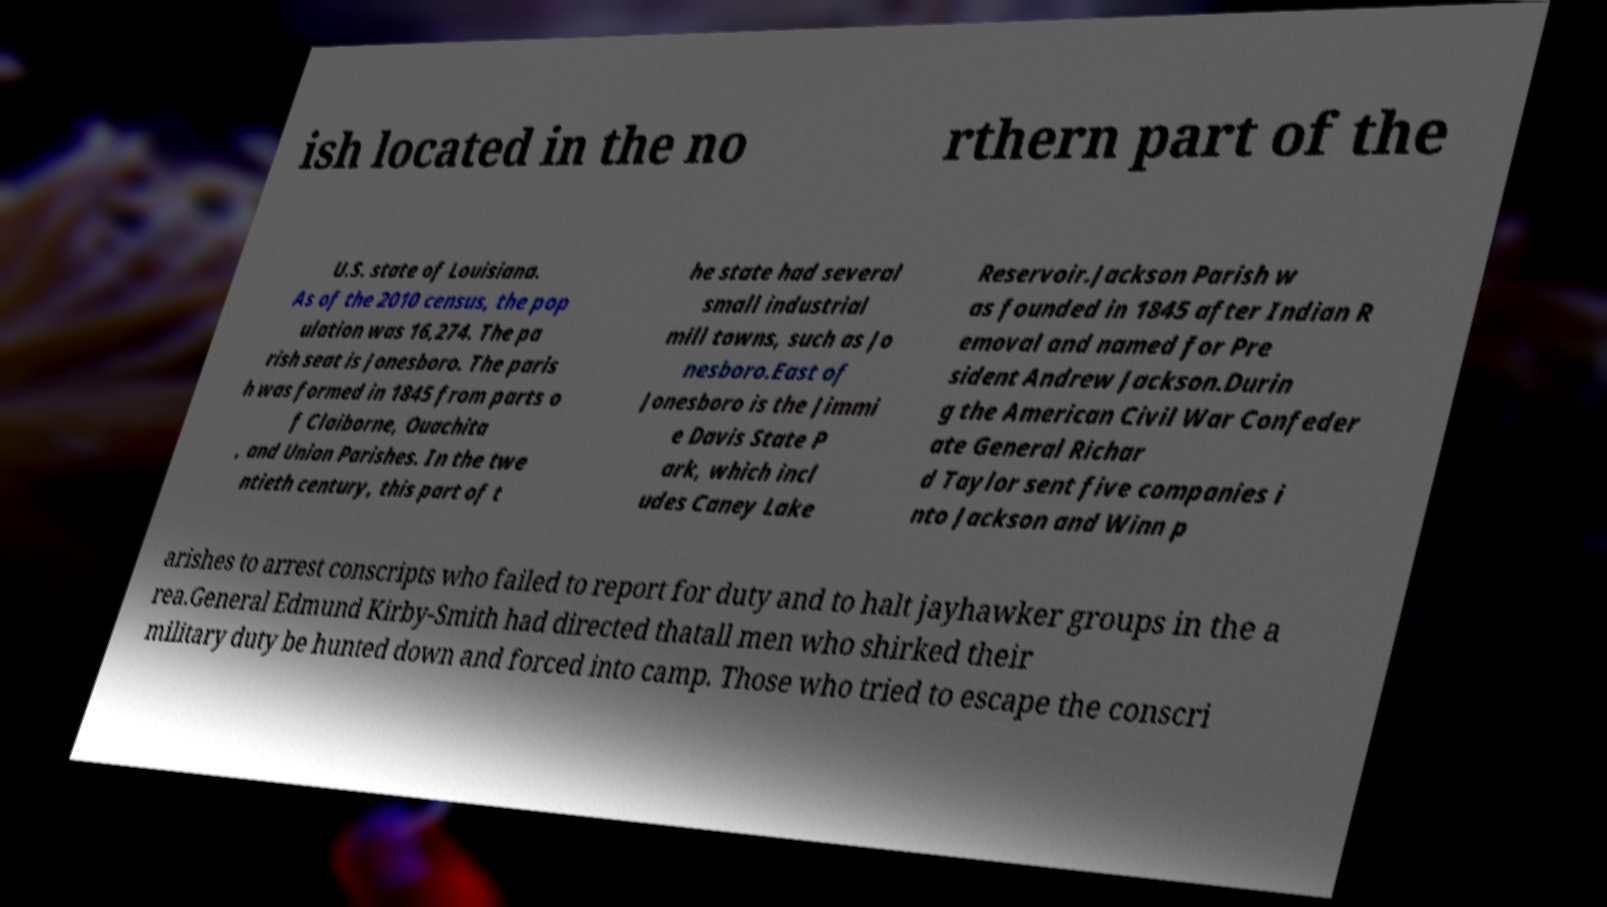Could you extract and type out the text from this image? ish located in the no rthern part of the U.S. state of Louisiana. As of the 2010 census, the pop ulation was 16,274. The pa rish seat is Jonesboro. The paris h was formed in 1845 from parts o f Claiborne, Ouachita , and Union Parishes. In the twe ntieth century, this part of t he state had several small industrial mill towns, such as Jo nesboro.East of Jonesboro is the Jimmi e Davis State P ark, which incl udes Caney Lake Reservoir.Jackson Parish w as founded in 1845 after Indian R emoval and named for Pre sident Andrew Jackson.Durin g the American Civil War Confeder ate General Richar d Taylor sent five companies i nto Jackson and Winn p arishes to arrest conscripts who failed to report for duty and to halt jayhawker groups in the a rea.General Edmund Kirby-Smith had directed thatall men who shirked their military duty be hunted down and forced into camp. Those who tried to escape the conscri 